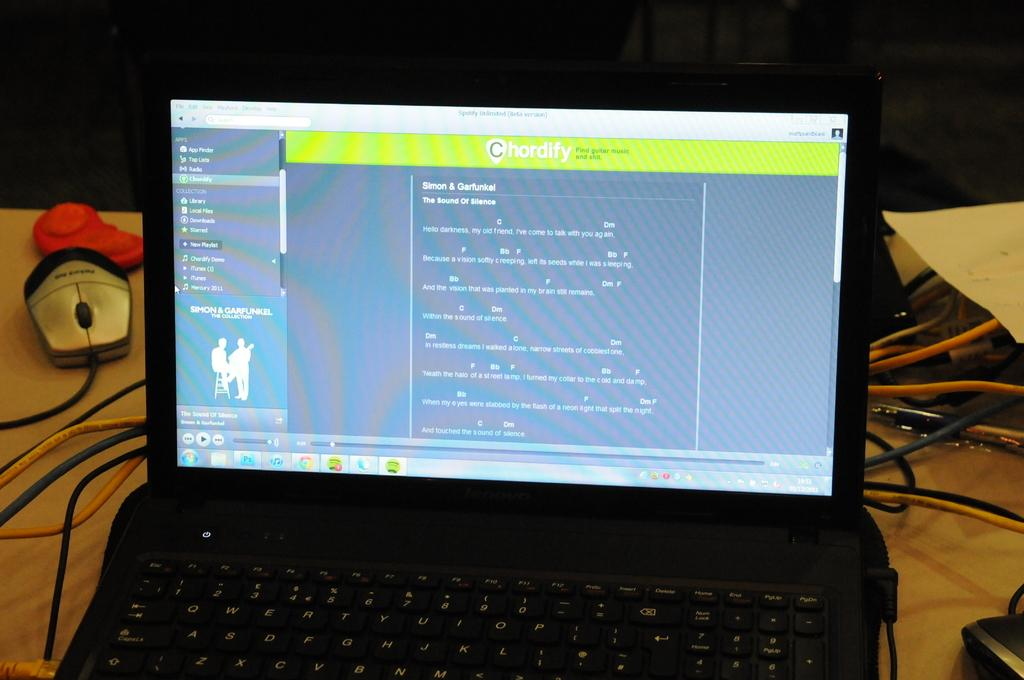<image>
Share a concise interpretation of the image provided. Chordify is the header of the web page shown on this laptop. 